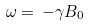<formula> <loc_0><loc_0><loc_500><loc_500>\omega = \, - \gamma B _ { 0 } \</formula> 